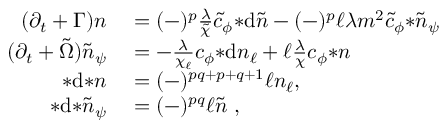Convert formula to latex. <formula><loc_0><loc_0><loc_500><loc_500>\begin{array} { r l } { ( \partial _ { t } + \Gamma ) n } & = ( - ) ^ { p } \frac { \lambda } { \tilde { \chi } } \tilde { c } _ { \phi } { * d \tilde { n } } - ( - ) ^ { p } \ell \lambda m ^ { 2 } \tilde { c } _ { \phi } { * \tilde { n } _ { \psi } } } \\ { ( \partial _ { t } + \tilde { \Omega } ) \tilde { n } _ { \psi } } & = - \frac { \lambda } { \chi _ { \ell } } c _ { \phi } { * d n _ { \ell } } + \ell \frac { \lambda } { \chi } c _ { \phi } { * n } } \\ { * d { * n } } & = ( - ) ^ { p q + p + q + 1 } \ell n _ { \ell } , } \\ { * d { * \tilde { n } _ { \psi } } } & = ( - ) ^ { p q } \ell \tilde { n } , } \end{array}</formula> 